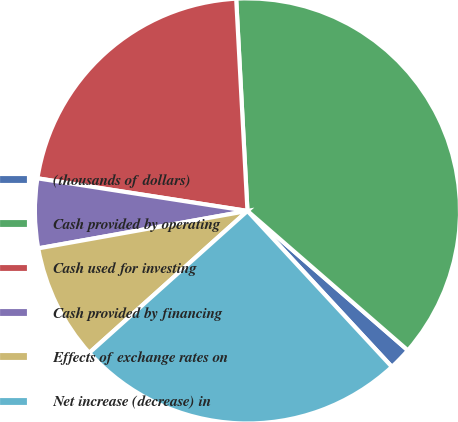Convert chart to OTSL. <chart><loc_0><loc_0><loc_500><loc_500><pie_chart><fcel>(thousands of dollars)<fcel>Cash provided by operating<fcel>Cash used for investing<fcel>Cash provided by financing<fcel>Effects of exchange rates on<fcel>Net increase (decrease) in<nl><fcel>1.72%<fcel>37.23%<fcel>21.7%<fcel>5.27%<fcel>8.82%<fcel>25.25%<nl></chart> 